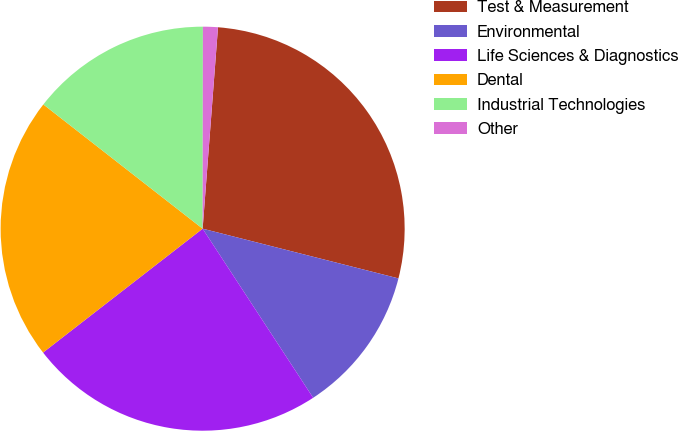<chart> <loc_0><loc_0><loc_500><loc_500><pie_chart><fcel>Test & Measurement<fcel>Environmental<fcel>Life Sciences & Diagnostics<fcel>Dental<fcel>Industrial Technologies<fcel>Other<nl><fcel>27.75%<fcel>11.83%<fcel>23.71%<fcel>21.05%<fcel>14.48%<fcel>1.19%<nl></chart> 